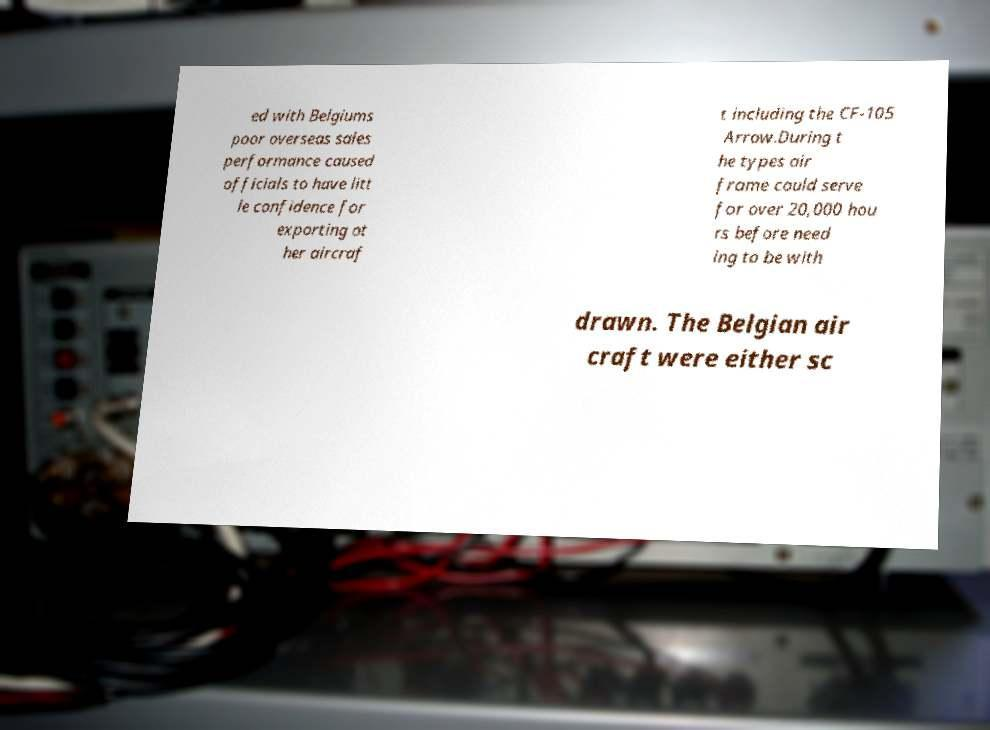Could you extract and type out the text from this image? ed with Belgiums poor overseas sales performance caused officials to have litt le confidence for exporting ot her aircraf t including the CF-105 Arrow.During t he types air frame could serve for over 20,000 hou rs before need ing to be with drawn. The Belgian air craft were either sc 